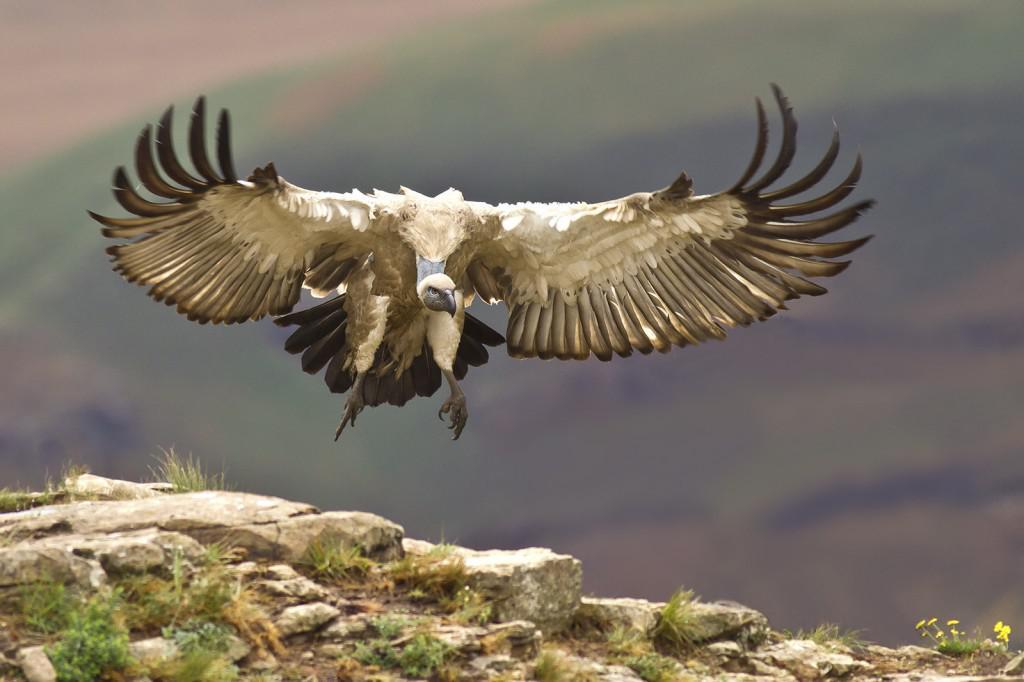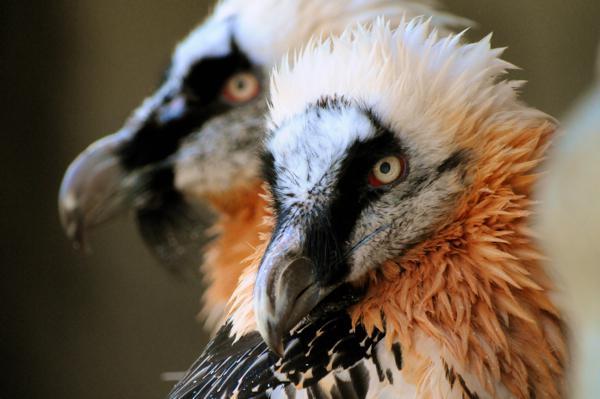The first image is the image on the left, the second image is the image on the right. For the images shown, is this caption "There is at least one bird sitting on a branch in each picture." true? Answer yes or no. No. 